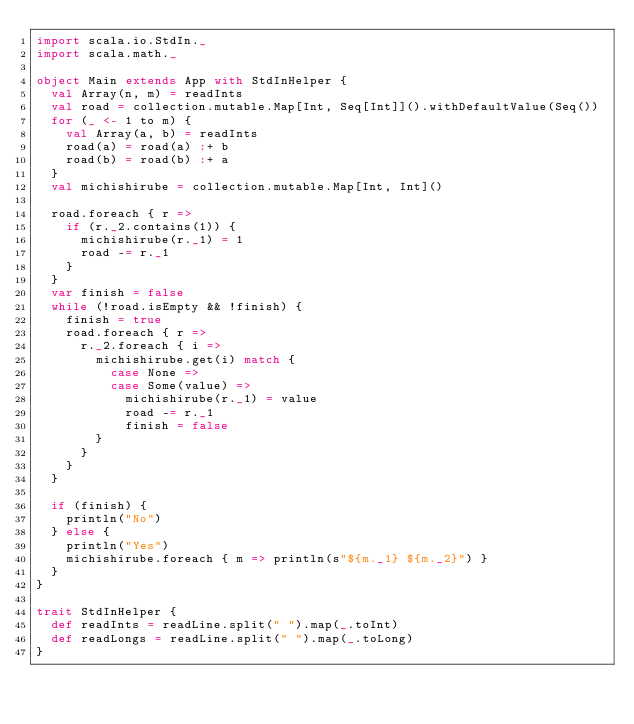<code> <loc_0><loc_0><loc_500><loc_500><_Scala_>import scala.io.StdIn._
import scala.math._

object Main extends App with StdInHelper {
  val Array(n, m) = readInts
  val road = collection.mutable.Map[Int, Seq[Int]]().withDefaultValue(Seq())
  for (_ <- 1 to m) {
    val Array(a, b) = readInts
    road(a) = road(a) :+ b
    road(b) = road(b) :+ a
  }
  val michishirube = collection.mutable.Map[Int, Int]()

  road.foreach { r =>
    if (r._2.contains(1)) {
      michishirube(r._1) = 1
      road -= r._1
    }
  }
  var finish = false
  while (!road.isEmpty && !finish) {
    finish = true
    road.foreach { r =>
      r._2.foreach { i =>
        michishirube.get(i) match {
          case None =>
          case Some(value) =>
            michishirube(r._1) = value
            road -= r._1
            finish = false
        }
      }
    }
  }

  if (finish) {
    println("No")
  } else {
    println("Yes")
    michishirube.foreach { m => println(s"${m._1} ${m._2}") }
  }
}

trait StdInHelper {
  def readInts = readLine.split(" ").map(_.toInt)
  def readLongs = readLine.split(" ").map(_.toLong)
}
</code> 